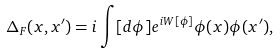Convert formula to latex. <formula><loc_0><loc_0><loc_500><loc_500>\Delta _ { F } ( x , x ^ { \prime } ) = i \int [ d \phi ] e ^ { i W [ \phi ] } \phi ( x ) \phi ( x ^ { \prime } ) ,</formula> 